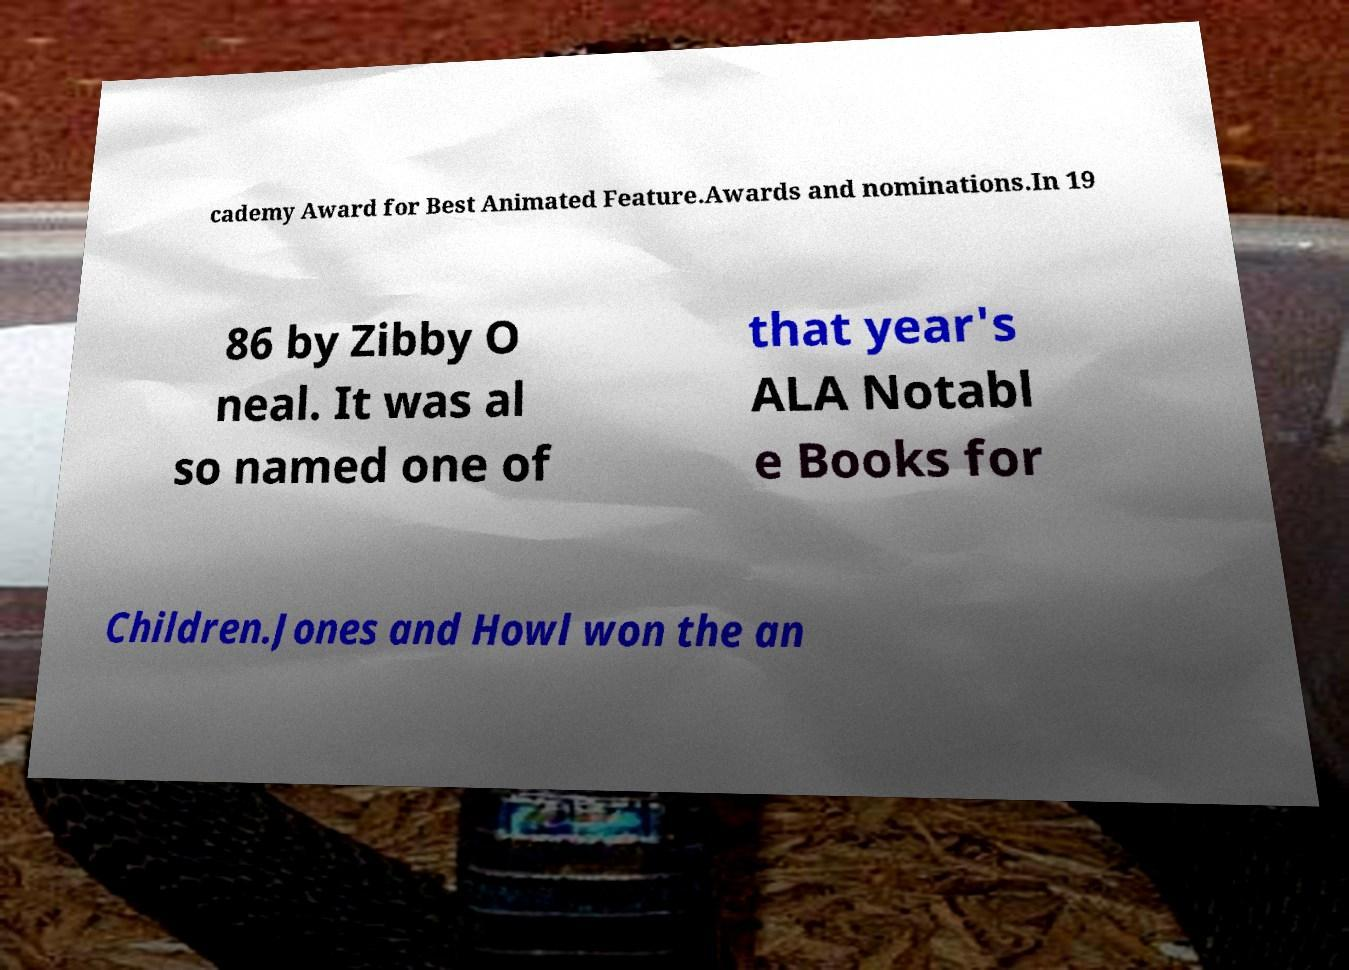Can you read and provide the text displayed in the image?This photo seems to have some interesting text. Can you extract and type it out for me? cademy Award for Best Animated Feature.Awards and nominations.In 19 86 by Zibby O neal. It was al so named one of that year's ALA Notabl e Books for Children.Jones and Howl won the an 